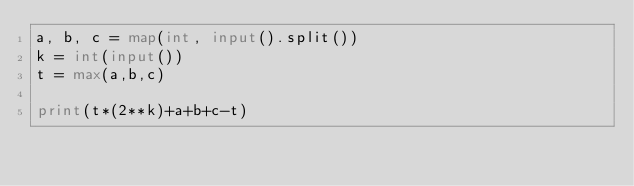<code> <loc_0><loc_0><loc_500><loc_500><_Python_>a, b, c = map(int, input().split())
k = int(input())
t = max(a,b,c)

print(t*(2**k)+a+b+c-t)</code> 